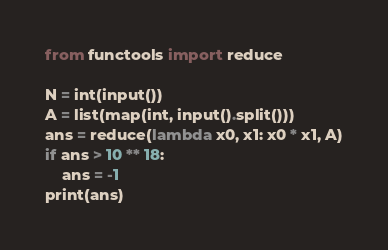Convert code to text. <code><loc_0><loc_0><loc_500><loc_500><_Python_>from functools import reduce

N = int(input())
A = list(map(int, input().split()))
ans = reduce(lambda x0, x1: x0 * x1, A)
if ans > 10 ** 18:
    ans = -1
print(ans)</code> 